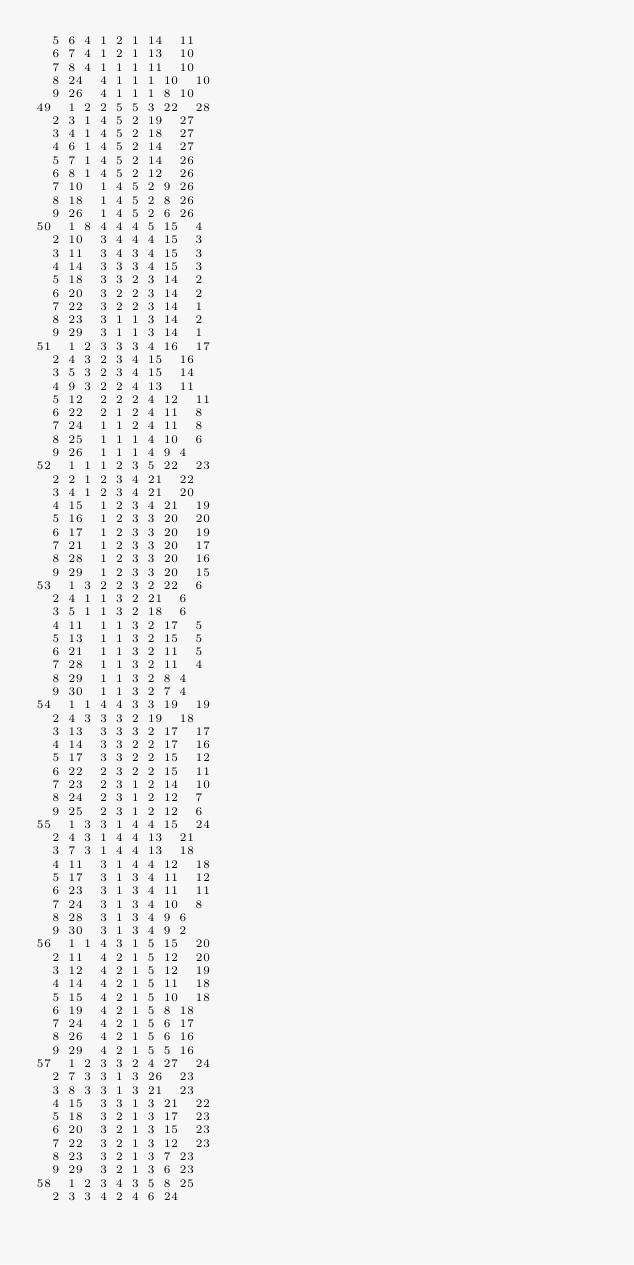<code> <loc_0><loc_0><loc_500><loc_500><_ObjectiveC_>	5	6	4	1	2	1	14	11	
	6	7	4	1	2	1	13	10	
	7	8	4	1	1	1	11	10	
	8	24	4	1	1	1	10	10	
	9	26	4	1	1	1	8	10	
49	1	2	2	5	5	3	22	28	
	2	3	1	4	5	2	19	27	
	3	4	1	4	5	2	18	27	
	4	6	1	4	5	2	14	27	
	5	7	1	4	5	2	14	26	
	6	8	1	4	5	2	12	26	
	7	10	1	4	5	2	9	26	
	8	18	1	4	5	2	8	26	
	9	26	1	4	5	2	6	26	
50	1	8	4	4	4	5	15	4	
	2	10	3	4	4	4	15	3	
	3	11	3	4	3	4	15	3	
	4	14	3	3	3	4	15	3	
	5	18	3	3	2	3	14	2	
	6	20	3	2	2	3	14	2	
	7	22	3	2	2	3	14	1	
	8	23	3	1	1	3	14	2	
	9	29	3	1	1	3	14	1	
51	1	2	3	3	3	4	16	17	
	2	4	3	2	3	4	15	16	
	3	5	3	2	3	4	15	14	
	4	9	3	2	2	4	13	11	
	5	12	2	2	2	4	12	11	
	6	22	2	1	2	4	11	8	
	7	24	1	1	2	4	11	8	
	8	25	1	1	1	4	10	6	
	9	26	1	1	1	4	9	4	
52	1	1	1	2	3	5	22	23	
	2	2	1	2	3	4	21	22	
	3	4	1	2	3	4	21	20	
	4	15	1	2	3	4	21	19	
	5	16	1	2	3	3	20	20	
	6	17	1	2	3	3	20	19	
	7	21	1	2	3	3	20	17	
	8	28	1	2	3	3	20	16	
	9	29	1	2	3	3	20	15	
53	1	3	2	2	3	2	22	6	
	2	4	1	1	3	2	21	6	
	3	5	1	1	3	2	18	6	
	4	11	1	1	3	2	17	5	
	5	13	1	1	3	2	15	5	
	6	21	1	1	3	2	11	5	
	7	28	1	1	3	2	11	4	
	8	29	1	1	3	2	8	4	
	9	30	1	1	3	2	7	4	
54	1	1	4	4	3	3	19	19	
	2	4	3	3	3	2	19	18	
	3	13	3	3	3	2	17	17	
	4	14	3	3	2	2	17	16	
	5	17	3	3	2	2	15	12	
	6	22	2	3	2	2	15	11	
	7	23	2	3	1	2	14	10	
	8	24	2	3	1	2	12	7	
	9	25	2	3	1	2	12	6	
55	1	3	3	1	4	4	15	24	
	2	4	3	1	4	4	13	21	
	3	7	3	1	4	4	13	18	
	4	11	3	1	4	4	12	18	
	5	17	3	1	3	4	11	12	
	6	23	3	1	3	4	11	11	
	7	24	3	1	3	4	10	8	
	8	28	3	1	3	4	9	6	
	9	30	3	1	3	4	9	2	
56	1	1	4	3	1	5	15	20	
	2	11	4	2	1	5	12	20	
	3	12	4	2	1	5	12	19	
	4	14	4	2	1	5	11	18	
	5	15	4	2	1	5	10	18	
	6	19	4	2	1	5	8	18	
	7	24	4	2	1	5	6	17	
	8	26	4	2	1	5	6	16	
	9	29	4	2	1	5	5	16	
57	1	2	3	3	2	4	27	24	
	2	7	3	3	1	3	26	23	
	3	8	3	3	1	3	21	23	
	4	15	3	3	1	3	21	22	
	5	18	3	2	1	3	17	23	
	6	20	3	2	1	3	15	23	
	7	22	3	2	1	3	12	23	
	8	23	3	2	1	3	7	23	
	9	29	3	2	1	3	6	23	
58	1	2	3	4	3	5	8	25	
	2	3	3	4	2	4	6	24	</code> 